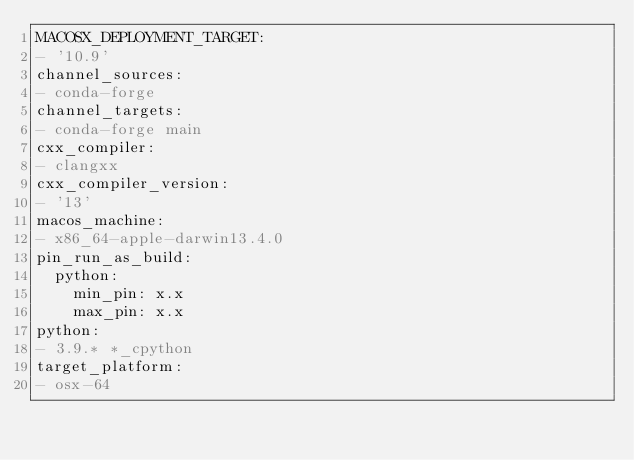Convert code to text. <code><loc_0><loc_0><loc_500><loc_500><_YAML_>MACOSX_DEPLOYMENT_TARGET:
- '10.9'
channel_sources:
- conda-forge
channel_targets:
- conda-forge main
cxx_compiler:
- clangxx
cxx_compiler_version:
- '13'
macos_machine:
- x86_64-apple-darwin13.4.0
pin_run_as_build:
  python:
    min_pin: x.x
    max_pin: x.x
python:
- 3.9.* *_cpython
target_platform:
- osx-64
</code> 